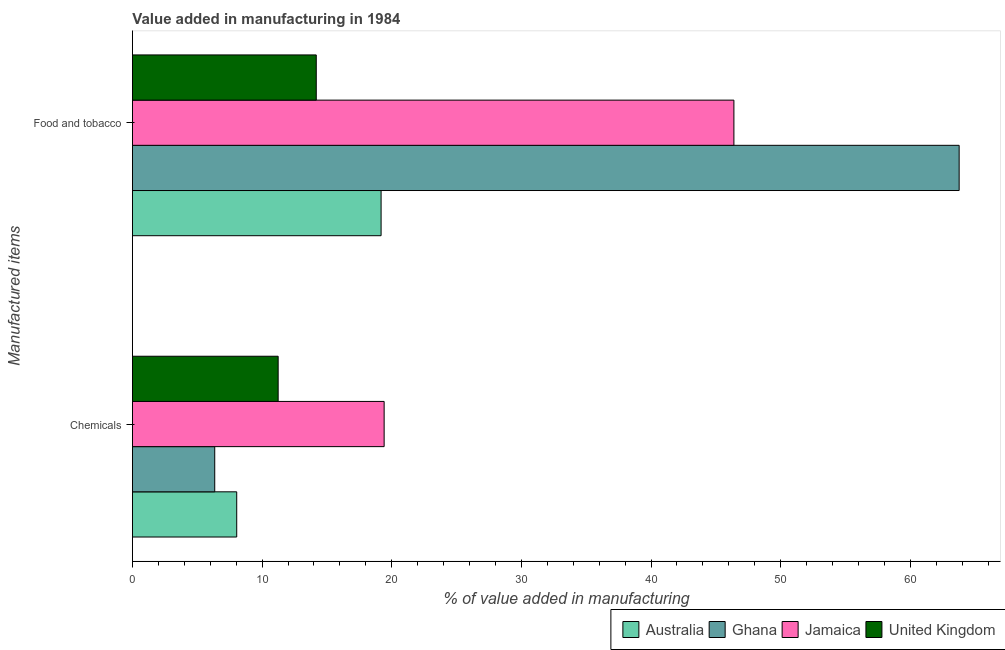How many different coloured bars are there?
Give a very brief answer. 4. How many groups of bars are there?
Offer a very short reply. 2. Are the number of bars on each tick of the Y-axis equal?
Your answer should be very brief. Yes. How many bars are there on the 1st tick from the top?
Keep it short and to the point. 4. What is the label of the 1st group of bars from the top?
Provide a succinct answer. Food and tobacco. What is the value added by  manufacturing chemicals in Ghana?
Provide a succinct answer. 6.35. Across all countries, what is the maximum value added by manufacturing food and tobacco?
Offer a very short reply. 63.76. Across all countries, what is the minimum value added by manufacturing food and tobacco?
Your answer should be compact. 14.18. In which country was the value added by  manufacturing chemicals maximum?
Keep it short and to the point. Jamaica. What is the total value added by manufacturing food and tobacco in the graph?
Provide a short and direct response. 143.51. What is the difference between the value added by  manufacturing chemicals in Ghana and that in Jamaica?
Give a very brief answer. -13.07. What is the difference between the value added by manufacturing food and tobacco in United Kingdom and the value added by  manufacturing chemicals in Ghana?
Your answer should be very brief. 7.83. What is the average value added by manufacturing food and tobacco per country?
Offer a terse response. 35.88. What is the difference between the value added by  manufacturing chemicals and value added by manufacturing food and tobacco in Ghana?
Provide a short and direct response. -57.42. In how many countries, is the value added by manufacturing food and tobacco greater than 38 %?
Provide a succinct answer. 2. What is the ratio of the value added by manufacturing food and tobacco in United Kingdom to that in Jamaica?
Provide a short and direct response. 0.31. In how many countries, is the value added by manufacturing food and tobacco greater than the average value added by manufacturing food and tobacco taken over all countries?
Provide a succinct answer. 2. What does the 3rd bar from the bottom in Food and tobacco represents?
Ensure brevity in your answer.  Jamaica. How many bars are there?
Keep it short and to the point. 8. Are all the bars in the graph horizontal?
Keep it short and to the point. Yes. Does the graph contain any zero values?
Make the answer very short. No. Where does the legend appear in the graph?
Ensure brevity in your answer.  Bottom right. How are the legend labels stacked?
Keep it short and to the point. Horizontal. What is the title of the graph?
Make the answer very short. Value added in manufacturing in 1984. What is the label or title of the X-axis?
Your response must be concise. % of value added in manufacturing. What is the label or title of the Y-axis?
Provide a short and direct response. Manufactured items. What is the % of value added in manufacturing in Australia in Chemicals?
Offer a terse response. 8.04. What is the % of value added in manufacturing in Ghana in Chemicals?
Offer a terse response. 6.35. What is the % of value added in manufacturing of Jamaica in Chemicals?
Make the answer very short. 19.41. What is the % of value added in manufacturing in United Kingdom in Chemicals?
Your answer should be very brief. 11.24. What is the % of value added in manufacturing in Australia in Food and tobacco?
Your answer should be compact. 19.18. What is the % of value added in manufacturing of Ghana in Food and tobacco?
Keep it short and to the point. 63.76. What is the % of value added in manufacturing in Jamaica in Food and tobacco?
Your answer should be compact. 46.39. What is the % of value added in manufacturing of United Kingdom in Food and tobacco?
Your answer should be very brief. 14.18. Across all Manufactured items, what is the maximum % of value added in manufacturing in Australia?
Your answer should be very brief. 19.18. Across all Manufactured items, what is the maximum % of value added in manufacturing in Ghana?
Your answer should be very brief. 63.76. Across all Manufactured items, what is the maximum % of value added in manufacturing in Jamaica?
Your answer should be compact. 46.39. Across all Manufactured items, what is the maximum % of value added in manufacturing in United Kingdom?
Your response must be concise. 14.18. Across all Manufactured items, what is the minimum % of value added in manufacturing in Australia?
Offer a terse response. 8.04. Across all Manufactured items, what is the minimum % of value added in manufacturing in Ghana?
Your response must be concise. 6.35. Across all Manufactured items, what is the minimum % of value added in manufacturing of Jamaica?
Provide a succinct answer. 19.41. Across all Manufactured items, what is the minimum % of value added in manufacturing of United Kingdom?
Make the answer very short. 11.24. What is the total % of value added in manufacturing in Australia in the graph?
Offer a very short reply. 27.22. What is the total % of value added in manufacturing of Ghana in the graph?
Your response must be concise. 70.11. What is the total % of value added in manufacturing in Jamaica in the graph?
Ensure brevity in your answer.  65.81. What is the total % of value added in manufacturing in United Kingdom in the graph?
Give a very brief answer. 25.42. What is the difference between the % of value added in manufacturing of Australia in Chemicals and that in Food and tobacco?
Ensure brevity in your answer.  -11.13. What is the difference between the % of value added in manufacturing in Ghana in Chemicals and that in Food and tobacco?
Offer a very short reply. -57.42. What is the difference between the % of value added in manufacturing in Jamaica in Chemicals and that in Food and tobacco?
Make the answer very short. -26.98. What is the difference between the % of value added in manufacturing in United Kingdom in Chemicals and that in Food and tobacco?
Make the answer very short. -2.94. What is the difference between the % of value added in manufacturing of Australia in Chemicals and the % of value added in manufacturing of Ghana in Food and tobacco?
Offer a terse response. -55.72. What is the difference between the % of value added in manufacturing of Australia in Chemicals and the % of value added in manufacturing of Jamaica in Food and tobacco?
Keep it short and to the point. -38.35. What is the difference between the % of value added in manufacturing in Australia in Chemicals and the % of value added in manufacturing in United Kingdom in Food and tobacco?
Give a very brief answer. -6.13. What is the difference between the % of value added in manufacturing in Ghana in Chemicals and the % of value added in manufacturing in Jamaica in Food and tobacco?
Your response must be concise. -40.04. What is the difference between the % of value added in manufacturing in Ghana in Chemicals and the % of value added in manufacturing in United Kingdom in Food and tobacco?
Keep it short and to the point. -7.83. What is the difference between the % of value added in manufacturing in Jamaica in Chemicals and the % of value added in manufacturing in United Kingdom in Food and tobacco?
Make the answer very short. 5.24. What is the average % of value added in manufacturing of Australia per Manufactured items?
Make the answer very short. 13.61. What is the average % of value added in manufacturing of Ghana per Manufactured items?
Ensure brevity in your answer.  35.06. What is the average % of value added in manufacturing in Jamaica per Manufactured items?
Provide a succinct answer. 32.9. What is the average % of value added in manufacturing in United Kingdom per Manufactured items?
Offer a very short reply. 12.71. What is the difference between the % of value added in manufacturing in Australia and % of value added in manufacturing in Ghana in Chemicals?
Your response must be concise. 1.7. What is the difference between the % of value added in manufacturing of Australia and % of value added in manufacturing of Jamaica in Chemicals?
Your answer should be very brief. -11.37. What is the difference between the % of value added in manufacturing of Australia and % of value added in manufacturing of United Kingdom in Chemicals?
Ensure brevity in your answer.  -3.2. What is the difference between the % of value added in manufacturing of Ghana and % of value added in manufacturing of Jamaica in Chemicals?
Give a very brief answer. -13.07. What is the difference between the % of value added in manufacturing in Ghana and % of value added in manufacturing in United Kingdom in Chemicals?
Provide a succinct answer. -4.89. What is the difference between the % of value added in manufacturing in Jamaica and % of value added in manufacturing in United Kingdom in Chemicals?
Give a very brief answer. 8.17. What is the difference between the % of value added in manufacturing of Australia and % of value added in manufacturing of Ghana in Food and tobacco?
Keep it short and to the point. -44.59. What is the difference between the % of value added in manufacturing of Australia and % of value added in manufacturing of Jamaica in Food and tobacco?
Your answer should be very brief. -27.21. What is the difference between the % of value added in manufacturing in Australia and % of value added in manufacturing in United Kingdom in Food and tobacco?
Offer a terse response. 5. What is the difference between the % of value added in manufacturing in Ghana and % of value added in manufacturing in Jamaica in Food and tobacco?
Your response must be concise. 17.37. What is the difference between the % of value added in manufacturing of Ghana and % of value added in manufacturing of United Kingdom in Food and tobacco?
Provide a short and direct response. 49.59. What is the difference between the % of value added in manufacturing in Jamaica and % of value added in manufacturing in United Kingdom in Food and tobacco?
Ensure brevity in your answer.  32.21. What is the ratio of the % of value added in manufacturing of Australia in Chemicals to that in Food and tobacco?
Your answer should be compact. 0.42. What is the ratio of the % of value added in manufacturing of Ghana in Chemicals to that in Food and tobacco?
Ensure brevity in your answer.  0.1. What is the ratio of the % of value added in manufacturing in Jamaica in Chemicals to that in Food and tobacco?
Your answer should be very brief. 0.42. What is the ratio of the % of value added in manufacturing in United Kingdom in Chemicals to that in Food and tobacco?
Provide a succinct answer. 0.79. What is the difference between the highest and the second highest % of value added in manufacturing in Australia?
Your answer should be compact. 11.13. What is the difference between the highest and the second highest % of value added in manufacturing in Ghana?
Your answer should be compact. 57.42. What is the difference between the highest and the second highest % of value added in manufacturing of Jamaica?
Provide a succinct answer. 26.98. What is the difference between the highest and the second highest % of value added in manufacturing of United Kingdom?
Provide a short and direct response. 2.94. What is the difference between the highest and the lowest % of value added in manufacturing of Australia?
Provide a succinct answer. 11.13. What is the difference between the highest and the lowest % of value added in manufacturing in Ghana?
Provide a short and direct response. 57.42. What is the difference between the highest and the lowest % of value added in manufacturing in Jamaica?
Ensure brevity in your answer.  26.98. What is the difference between the highest and the lowest % of value added in manufacturing in United Kingdom?
Offer a terse response. 2.94. 